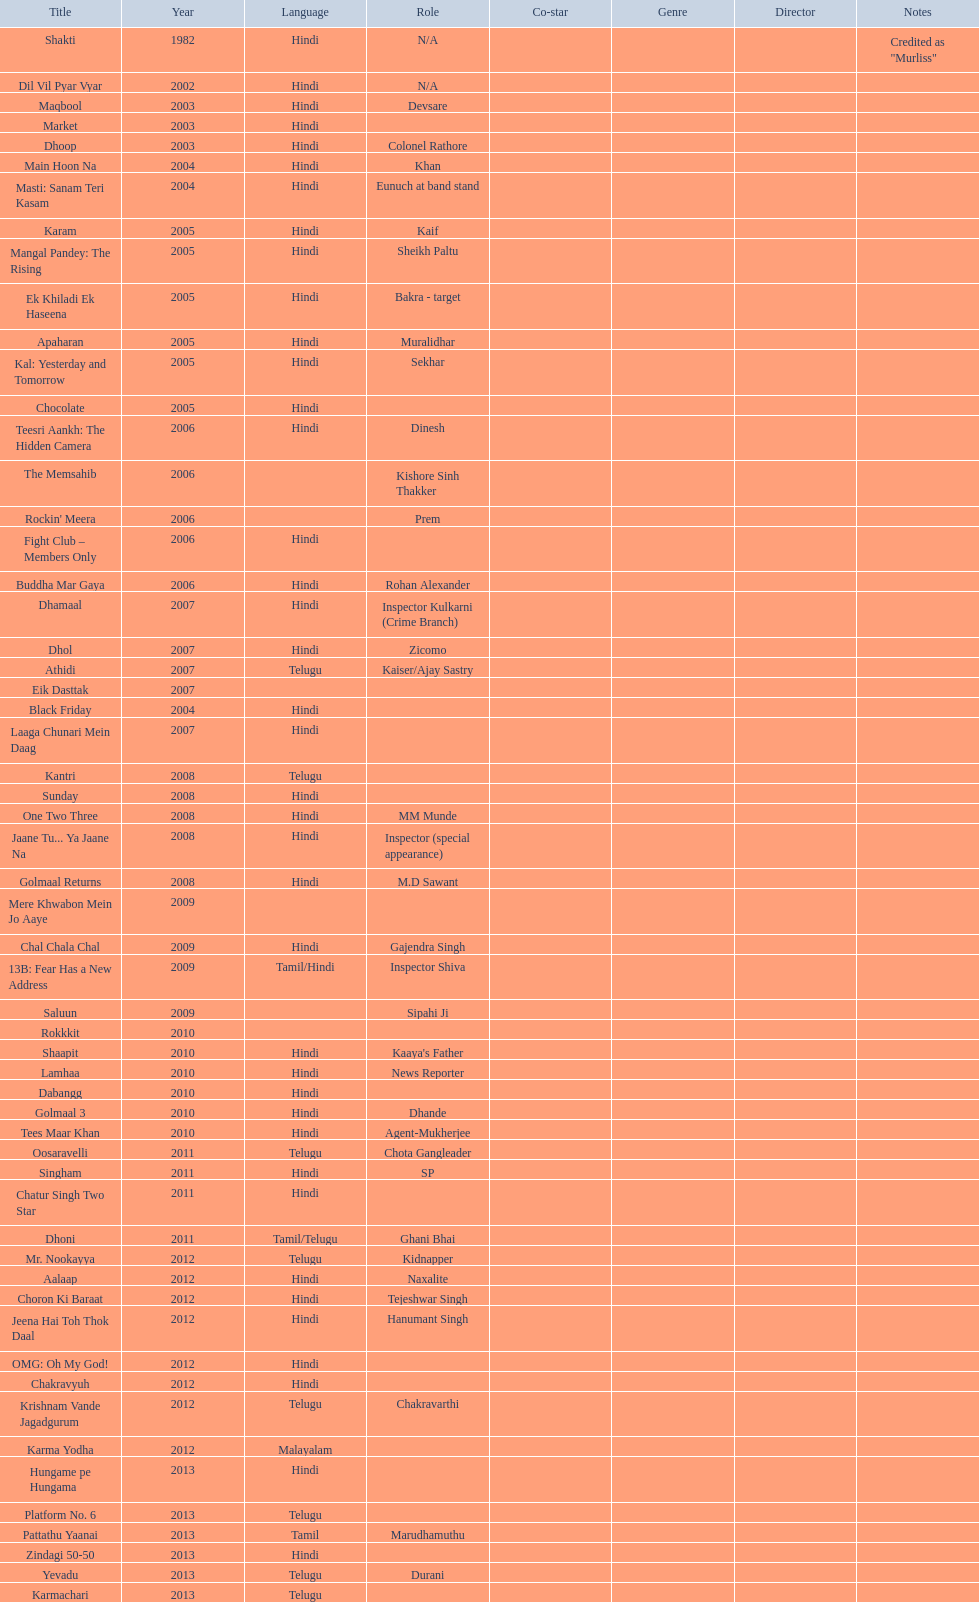What are the number of titles listed in 2005? 6. 